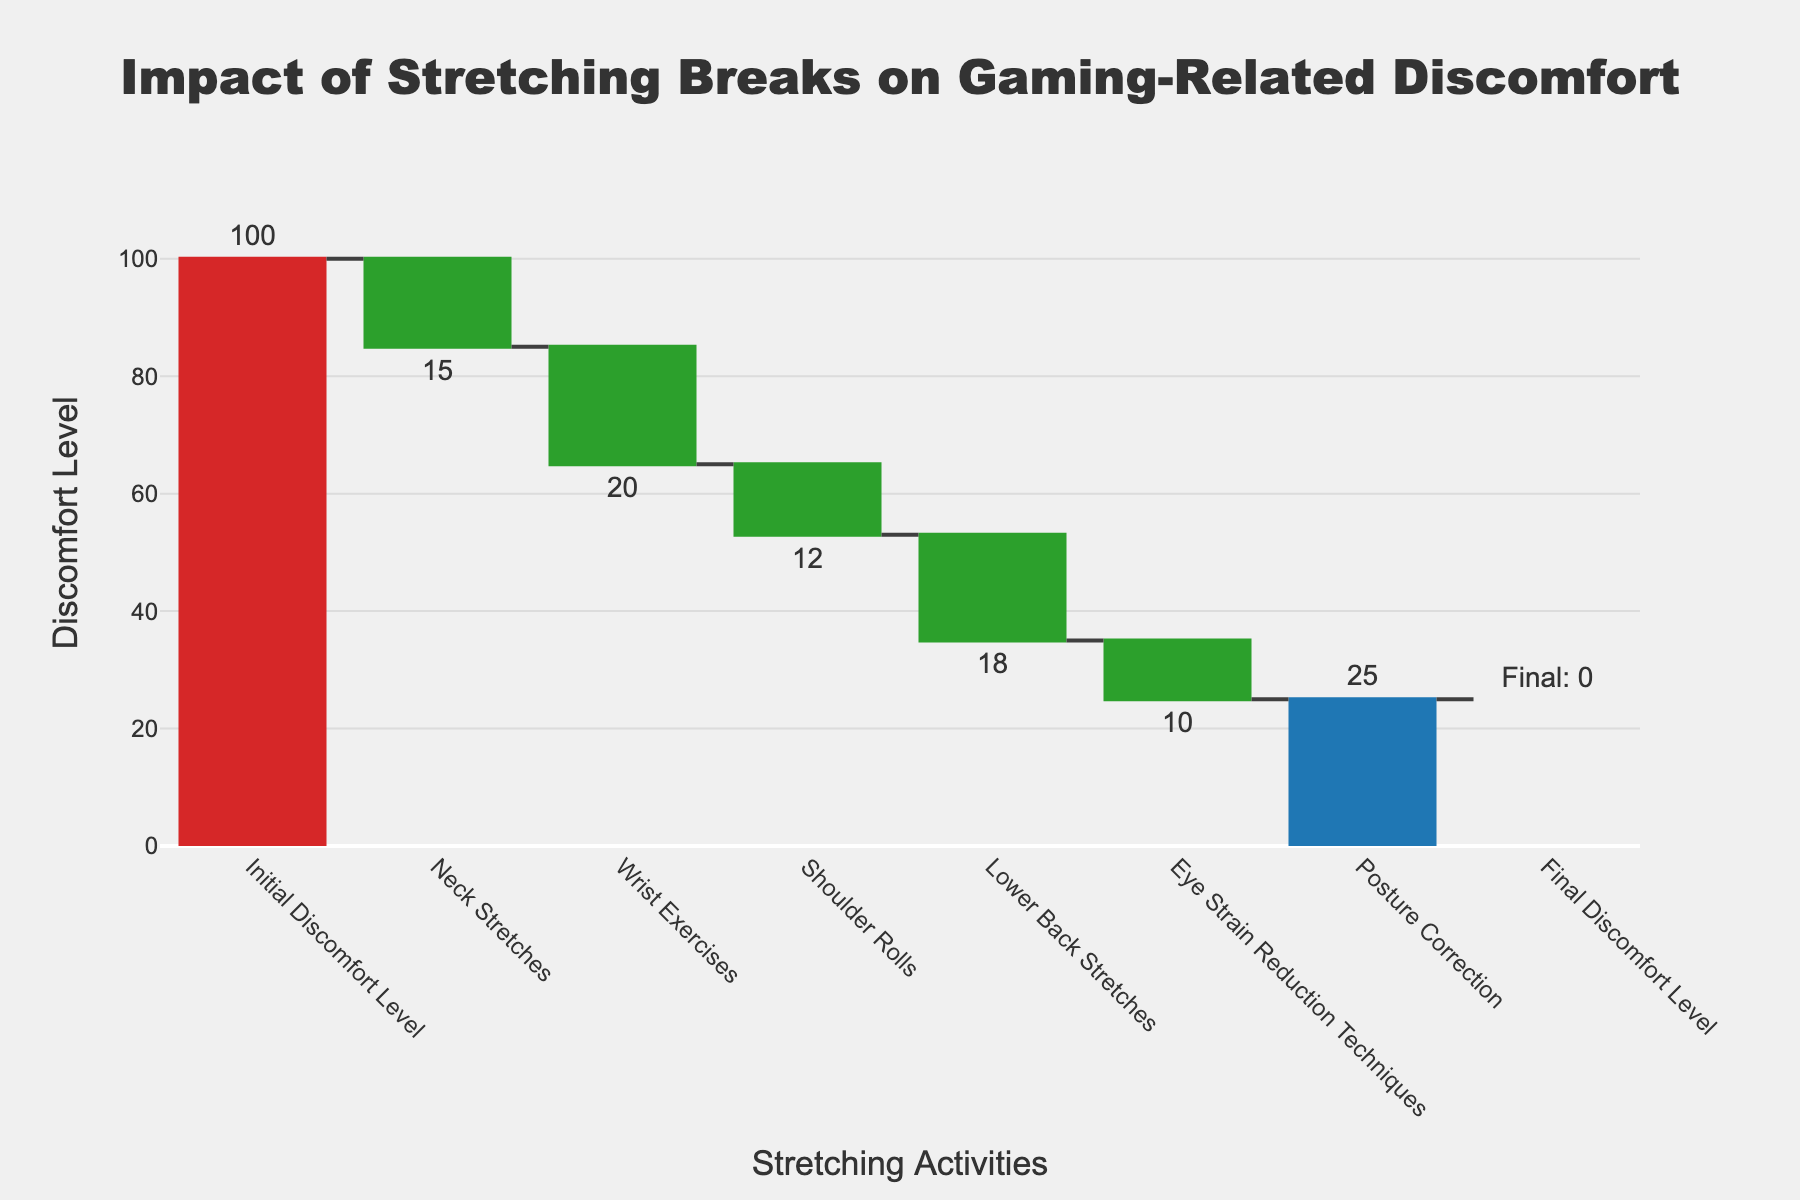What's the title of the chart? The title of the chart is located at the top center of the figure.
Answer: Impact of Stretching Breaks on Gaming-Related Discomfort How many stretching activities are listed in the chart? Count the number of categories excluding "Initial Discomfort Level" and "Final Discomfort Level".
Answer: 6 Which stretching activity reduces discomfort the most? Compare the discomfort reduction values of each activity and identify the one with the highest negative value. "Posture Correction" reduces by 25, which is the highest.
Answer: Posture Correction What is the cumulative reduction in discomfort from shoulder rolls and lower back stretches? Add the reductions from "Shoulder Rolls" (-12) and "Lower Back Stretches" (-18) together. -12 + -18 = -30.
Answer: -30 What impact do eye strain reduction techniques have on discomfort level? Look at the value corresponding to "Eye Strain Reduction Techniques". It shows a reduction by 10.
Answer: Reduces by 10 Which category reduced the discomfort the least? Compare the reductions in each category and find the smallest negative value. "Eye Strain Reduction Techniques" reduces by -10, which is the least.
Answer: Eye Strain Reduction Techniques What is the discomfort level after implementing shoulder rolls? Subtract the impact of each preceding activity from the initial discomfort until reaching "Shoulder Rolls". Initial: 100 -> Neck Stretches: 85 -> Wrist Exercises: 65 -> Shoulder Rolls: 53.
Answer: 53 How much more effective is posture correction compared to neck stretches? Subtract the impact of neck stretches (-15) from the impact of posture correction (-25). -25 - -15 = -10.
Answer: 10 What's the final discomfort level after all activities? The last category "Final Discomfort Level" indicates the value directly.
Answer: 0 Explain what the total bar in the waterfall chart represents. The total bar in the waterfall chart represents the cumulative effect of all the prior increases and decreases, leading to the final discomfort level.
Answer: Cumulative effect 